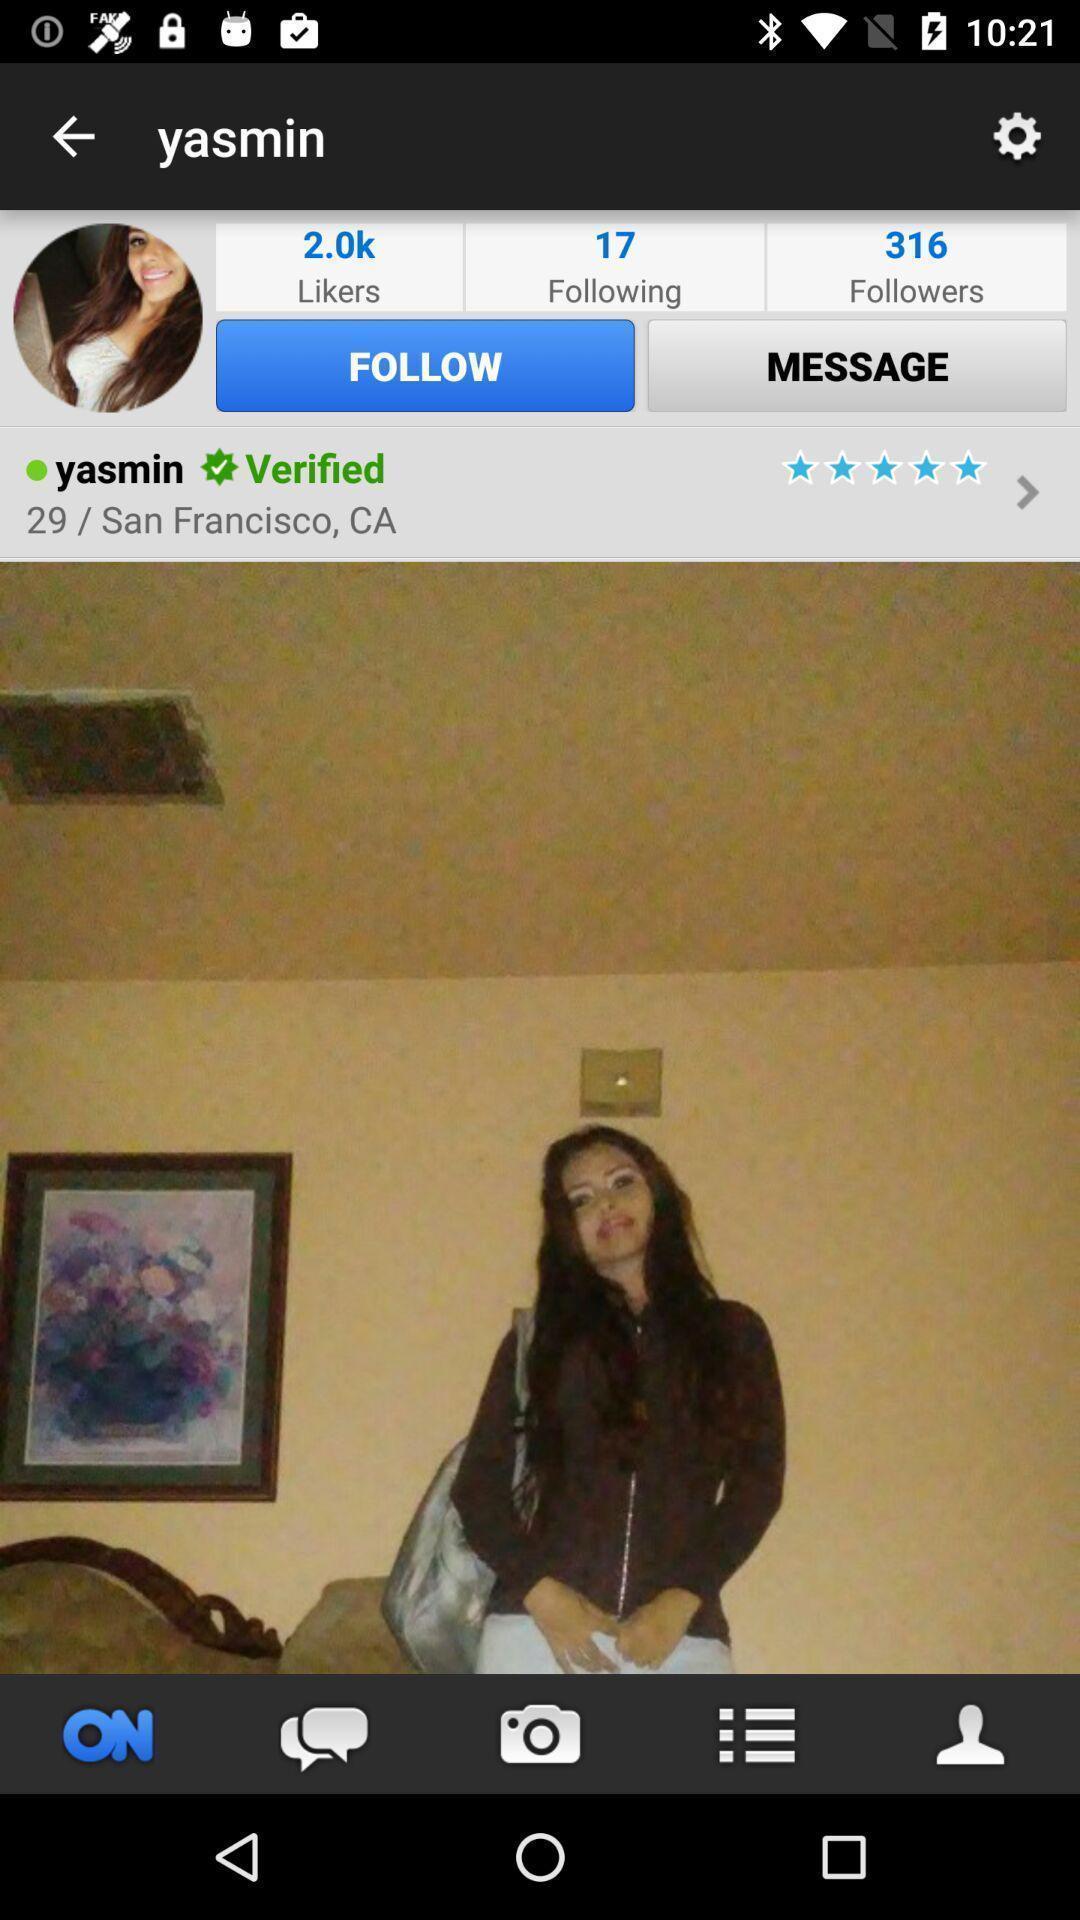Provide a description of this screenshot. Profile page. 